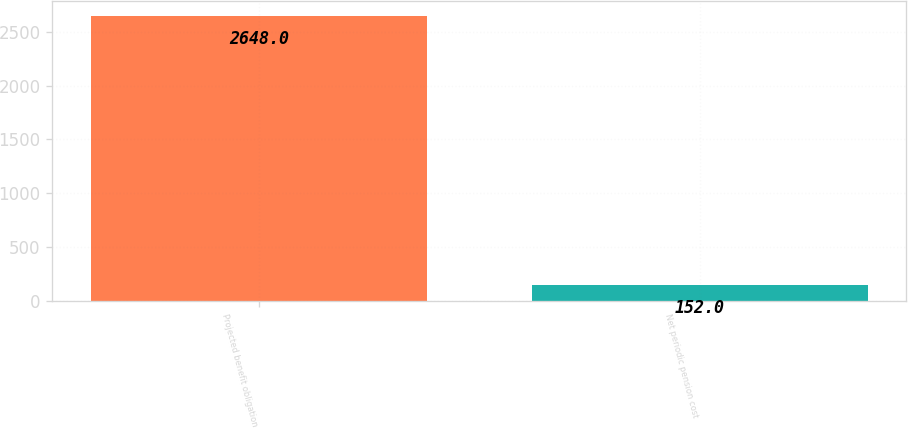Convert chart to OTSL. <chart><loc_0><loc_0><loc_500><loc_500><bar_chart><fcel>Projected benefit obligation<fcel>Net periodic pension cost<nl><fcel>2648<fcel>152<nl></chart> 